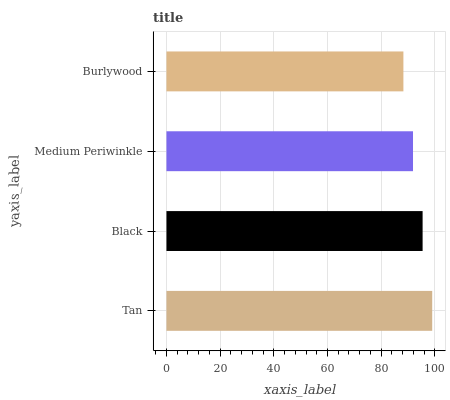Is Burlywood the minimum?
Answer yes or no. Yes. Is Tan the maximum?
Answer yes or no. Yes. Is Black the minimum?
Answer yes or no. No. Is Black the maximum?
Answer yes or no. No. Is Tan greater than Black?
Answer yes or no. Yes. Is Black less than Tan?
Answer yes or no. Yes. Is Black greater than Tan?
Answer yes or no. No. Is Tan less than Black?
Answer yes or no. No. Is Black the high median?
Answer yes or no. Yes. Is Medium Periwinkle the low median?
Answer yes or no. Yes. Is Tan the high median?
Answer yes or no. No. Is Burlywood the low median?
Answer yes or no. No. 